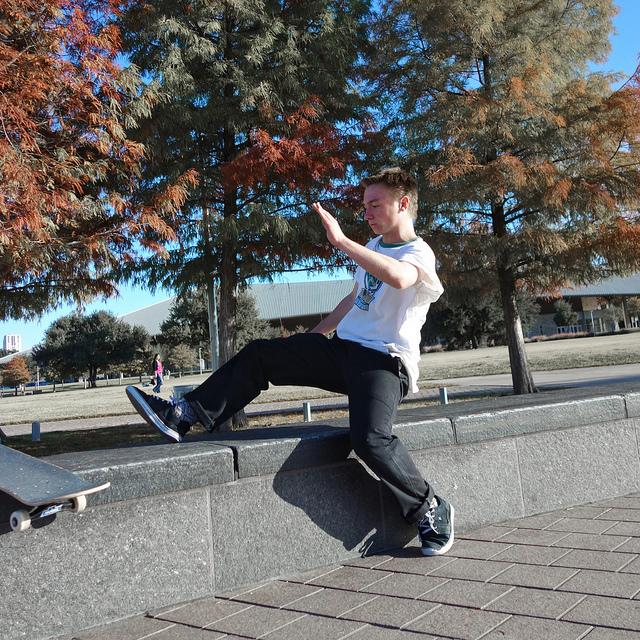Are there spectators?
Quick response, please. No. What are they taking pictures of?
Answer briefly. Skateboarding. What season is this?
Give a very brief answer. Fall. What trick is the man performing?
Concise answer only. Falling. Is the man falling?
Keep it brief. Yes. What is he riding?
Be succinct. Skateboard. What is left to the man?
Keep it brief. Skateboard. 